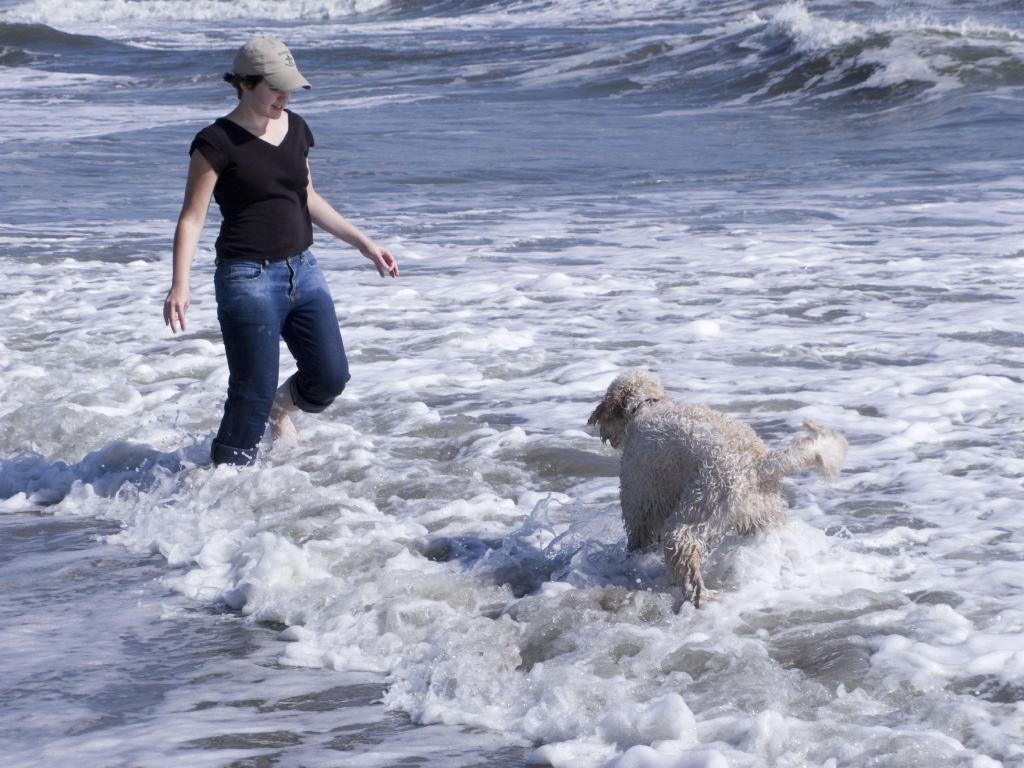What is located in the foreground of the image? There is a dog and a person in the foreground of the image. What is the setting of the image? Both the dog and the person are in the water. What type of station can be seen in the background of the image? There is no station present in the image; it features a dog and a person in the water. What season is depicted in the image? The provided facts do not mention any seasonal details, so it cannot be determined from the image. 